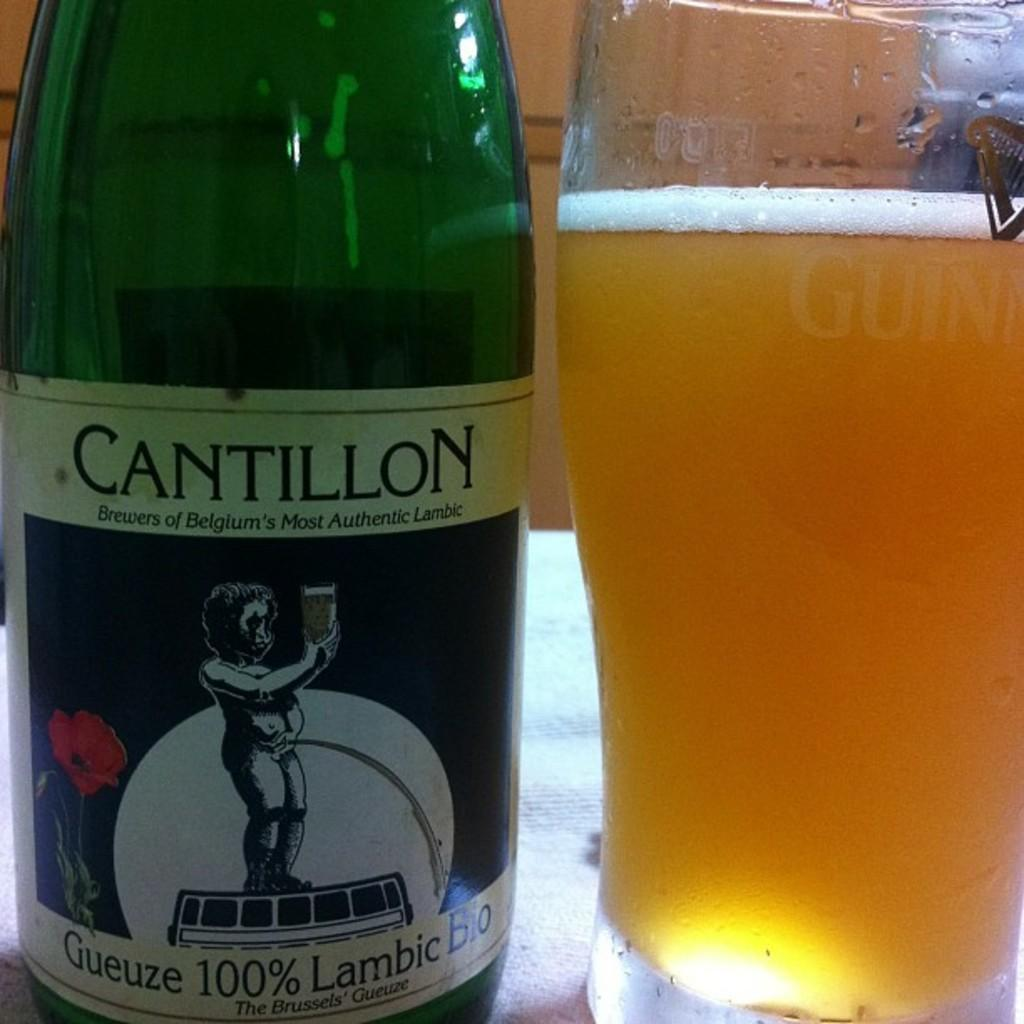<image>
Create a compact narrative representing the image presented. the word cantillon that is on a bottle 